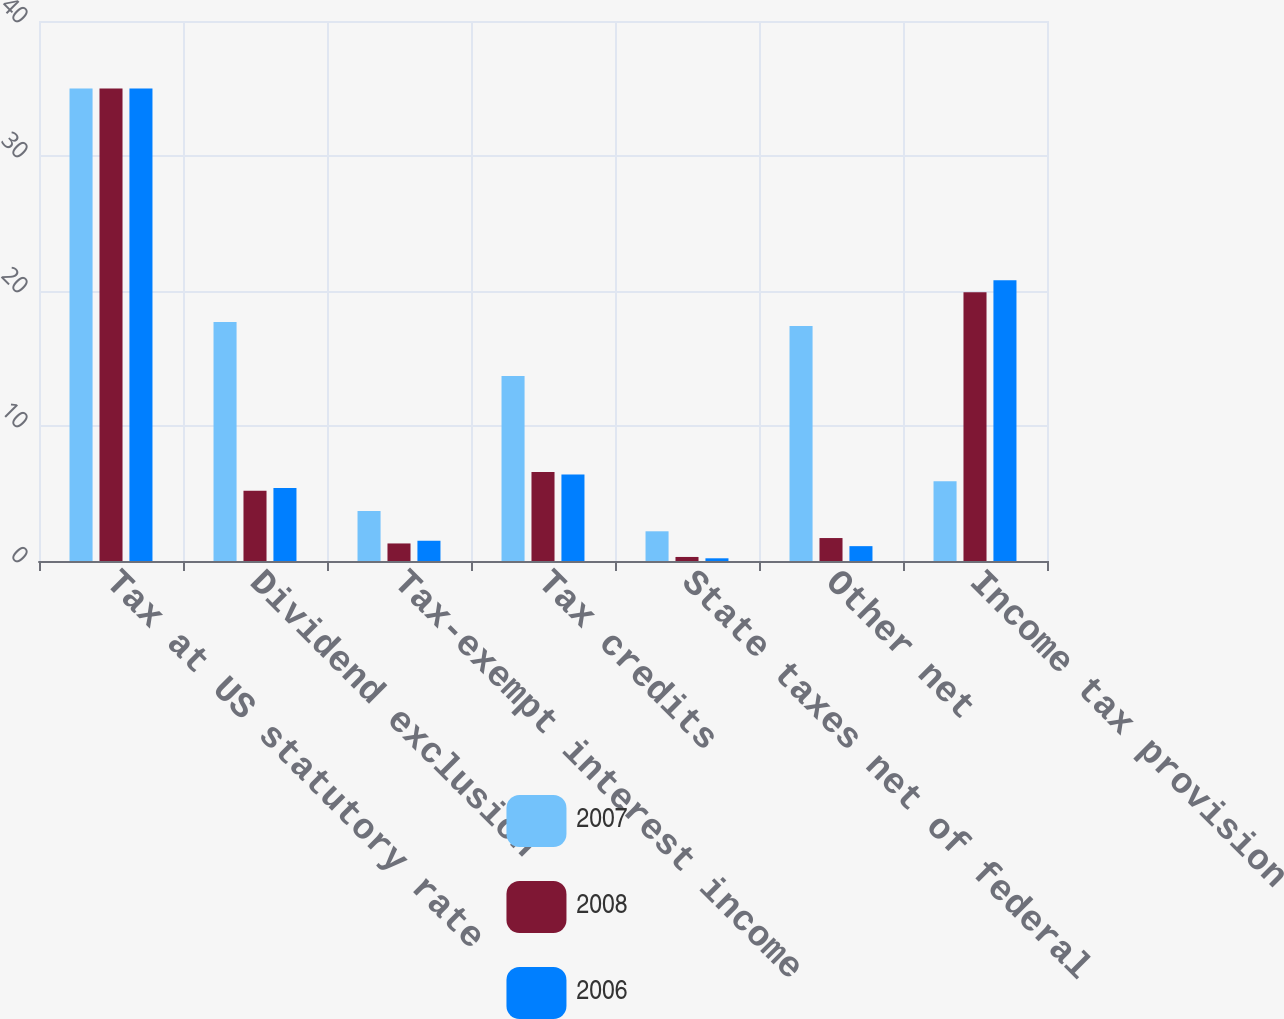Convert chart to OTSL. <chart><loc_0><loc_0><loc_500><loc_500><stacked_bar_chart><ecel><fcel>Tax at US statutory rate<fcel>Dividend exclusion<fcel>Tax-exempt interest income<fcel>Tax credits<fcel>State taxes net of federal<fcel>Other net<fcel>Income tax provision<nl><fcel>2007<fcel>35<fcel>17.7<fcel>3.7<fcel>13.7<fcel>2.2<fcel>17.4<fcel>5.9<nl><fcel>2008<fcel>35<fcel>5.2<fcel>1.3<fcel>6.6<fcel>0.3<fcel>1.7<fcel>19.9<nl><fcel>2006<fcel>35<fcel>5.4<fcel>1.5<fcel>6.4<fcel>0.2<fcel>1.1<fcel>20.8<nl></chart> 